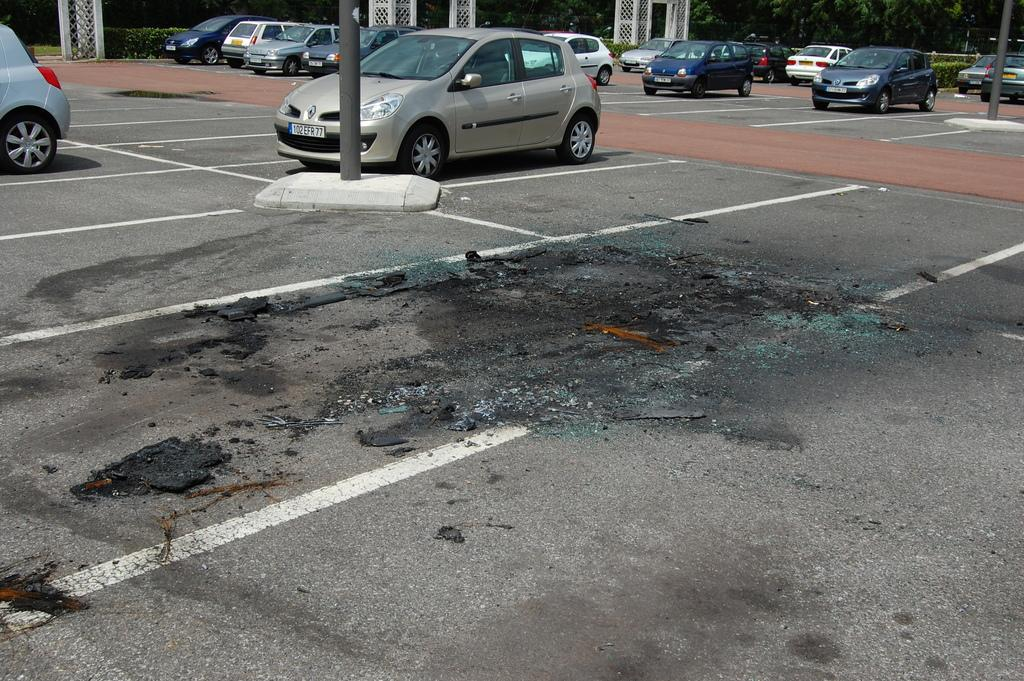What is in the foreground of the image? There is a road in the foreground of the image. What can be seen on the road? Waste materials are present on the road. What is located in the middle of the image? There are poles and cars visible in the middle of the image. What is visible in the background of the image? Trees, plants, and iron frames are observable in the background of the image. Can you tell me who won the fight in the image? There is no fight present in the image. What type of hat is the person wearing in the image? There are no people or hats present in the image. 